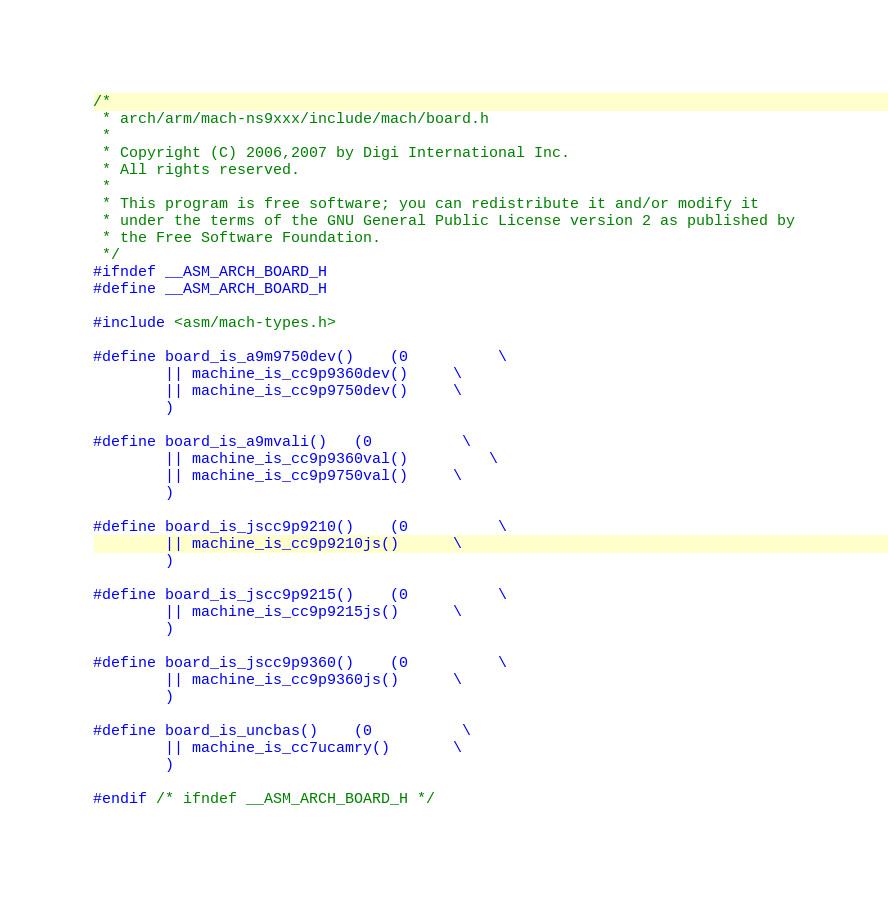Convert code to text. <code><loc_0><loc_0><loc_500><loc_500><_C_>/*
 * arch/arm/mach-ns9xxx/include/mach/board.h
 *
 * Copyright (C) 2006,2007 by Digi International Inc.
 * All rights reserved.
 *
 * This program is free software; you can redistribute it and/or modify it
 * under the terms of the GNU General Public License version 2 as published by
 * the Free Software Foundation.
 */
#ifndef __ASM_ARCH_BOARD_H
#define __ASM_ARCH_BOARD_H

#include <asm/mach-types.h>

#define board_is_a9m9750dev()	(0			\
		|| machine_is_cc9p9360dev()		\
		|| machine_is_cc9p9750dev()		\
		)

#define board_is_a9mvali()	(0			\
		|| machine_is_cc9p9360val() 		\
		|| machine_is_cc9p9750val()		\
		)

#define board_is_jscc9p9210()	(0			\
		|| machine_is_cc9p9210js()		\
		)

#define board_is_jscc9p9215()	(0			\
		|| machine_is_cc9p9215js()		\
		)

#define board_is_jscc9p9360()	(0			\
		|| machine_is_cc9p9360js()		\
		)

#define board_is_uncbas()	(0			\
		|| machine_is_cc7ucamry()		\
		)

#endif /* ifndef __ASM_ARCH_BOARD_H */
</code> 